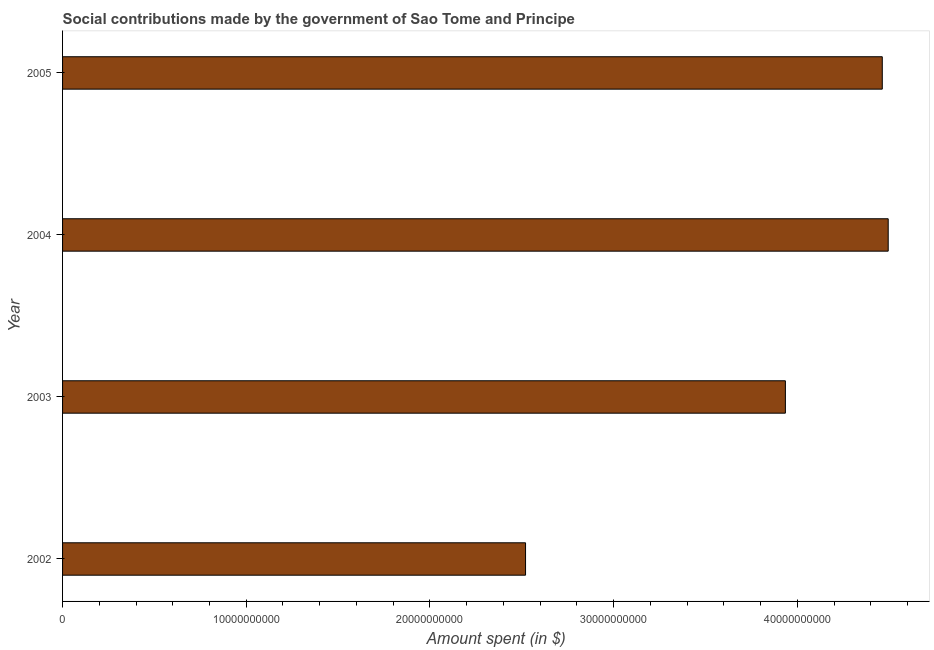Does the graph contain grids?
Keep it short and to the point. No. What is the title of the graph?
Provide a succinct answer. Social contributions made by the government of Sao Tome and Principe. What is the label or title of the X-axis?
Ensure brevity in your answer.  Amount spent (in $). What is the label or title of the Y-axis?
Keep it short and to the point. Year. What is the amount spent in making social contributions in 2002?
Provide a succinct answer. 2.52e+1. Across all years, what is the maximum amount spent in making social contributions?
Offer a terse response. 4.50e+1. Across all years, what is the minimum amount spent in making social contributions?
Give a very brief answer. 2.52e+1. In which year was the amount spent in making social contributions maximum?
Provide a succinct answer. 2004. What is the sum of the amount spent in making social contributions?
Give a very brief answer. 1.54e+11. What is the difference between the amount spent in making social contributions in 2002 and 2005?
Offer a very short reply. -1.94e+1. What is the average amount spent in making social contributions per year?
Offer a very short reply. 3.85e+1. What is the median amount spent in making social contributions?
Ensure brevity in your answer.  4.20e+1. Do a majority of the years between 2002 and 2003 (inclusive) have amount spent in making social contributions greater than 38000000000 $?
Give a very brief answer. No. What is the ratio of the amount spent in making social contributions in 2002 to that in 2003?
Make the answer very short. 0.64. Is the amount spent in making social contributions in 2002 less than that in 2005?
Your answer should be compact. Yes. What is the difference between the highest and the second highest amount spent in making social contributions?
Keep it short and to the point. 3.23e+08. Is the sum of the amount spent in making social contributions in 2002 and 2003 greater than the maximum amount spent in making social contributions across all years?
Provide a succinct answer. Yes. What is the difference between the highest and the lowest amount spent in making social contributions?
Keep it short and to the point. 1.97e+1. In how many years, is the amount spent in making social contributions greater than the average amount spent in making social contributions taken over all years?
Give a very brief answer. 3. How many bars are there?
Offer a terse response. 4. Are all the bars in the graph horizontal?
Offer a terse response. Yes. Are the values on the major ticks of X-axis written in scientific E-notation?
Offer a very short reply. No. What is the Amount spent (in $) of 2002?
Your answer should be compact. 2.52e+1. What is the Amount spent (in $) of 2003?
Make the answer very short. 3.94e+1. What is the Amount spent (in $) in 2004?
Make the answer very short. 4.50e+1. What is the Amount spent (in $) in 2005?
Ensure brevity in your answer.  4.46e+1. What is the difference between the Amount spent (in $) in 2002 and 2003?
Give a very brief answer. -1.41e+1. What is the difference between the Amount spent (in $) in 2002 and 2004?
Offer a terse response. -1.97e+1. What is the difference between the Amount spent (in $) in 2002 and 2005?
Your answer should be very brief. -1.94e+1. What is the difference between the Amount spent (in $) in 2003 and 2004?
Give a very brief answer. -5.60e+09. What is the difference between the Amount spent (in $) in 2003 and 2005?
Make the answer very short. -5.28e+09. What is the difference between the Amount spent (in $) in 2004 and 2005?
Your response must be concise. 3.23e+08. What is the ratio of the Amount spent (in $) in 2002 to that in 2003?
Ensure brevity in your answer.  0.64. What is the ratio of the Amount spent (in $) in 2002 to that in 2004?
Keep it short and to the point. 0.56. What is the ratio of the Amount spent (in $) in 2002 to that in 2005?
Your answer should be compact. 0.56. What is the ratio of the Amount spent (in $) in 2003 to that in 2004?
Provide a succinct answer. 0.88. What is the ratio of the Amount spent (in $) in 2003 to that in 2005?
Ensure brevity in your answer.  0.88. 